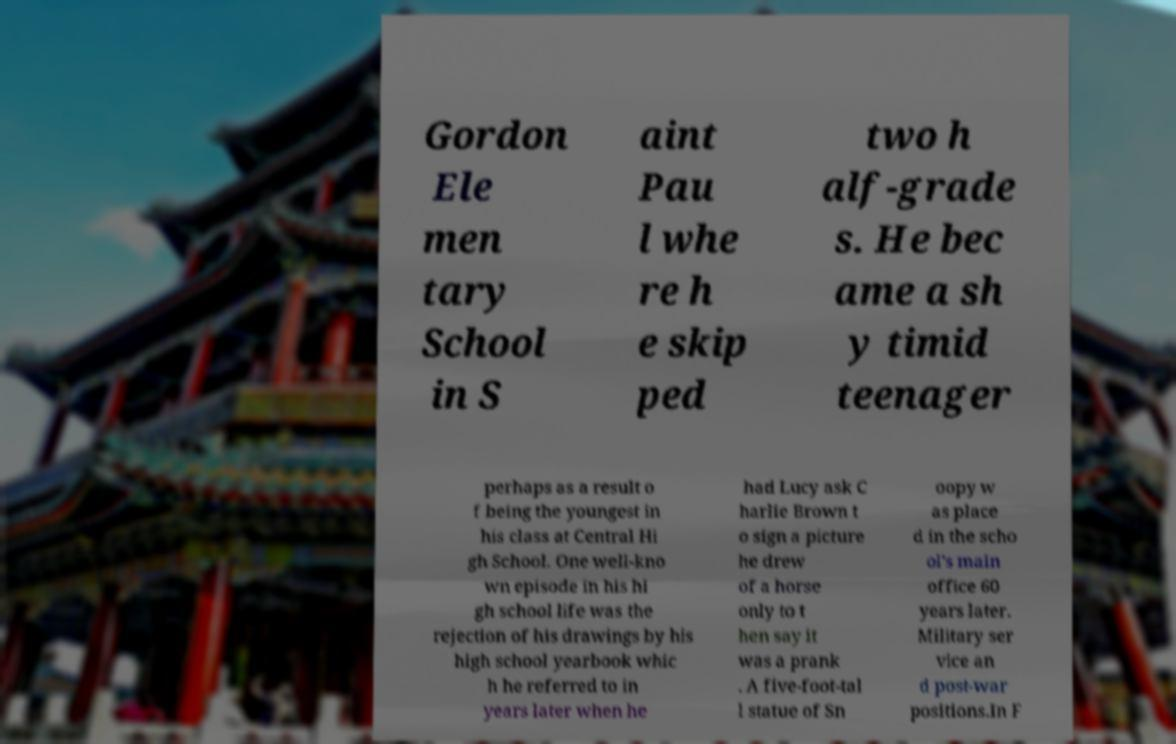Please identify and transcribe the text found in this image. Gordon Ele men tary School in S aint Pau l whe re h e skip ped two h alf-grade s. He bec ame a sh y timid teenager perhaps as a result o f being the youngest in his class at Central Hi gh School. One well-kno wn episode in his hi gh school life was the rejection of his drawings by his high school yearbook whic h he referred to in years later when he had Lucy ask C harlie Brown t o sign a picture he drew of a horse only to t hen say it was a prank . A five-foot-tal l statue of Sn oopy w as place d in the scho ol's main office 60 years later. Military ser vice an d post-war positions.In F 